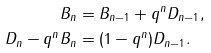<formula> <loc_0><loc_0><loc_500><loc_500>B _ { n } & = B _ { n - 1 } + q ^ { n } D _ { n - 1 } , \\ D _ { n } - q ^ { n } B _ { n } & = ( 1 - q ^ { n } ) D _ { n - 1 } .</formula> 